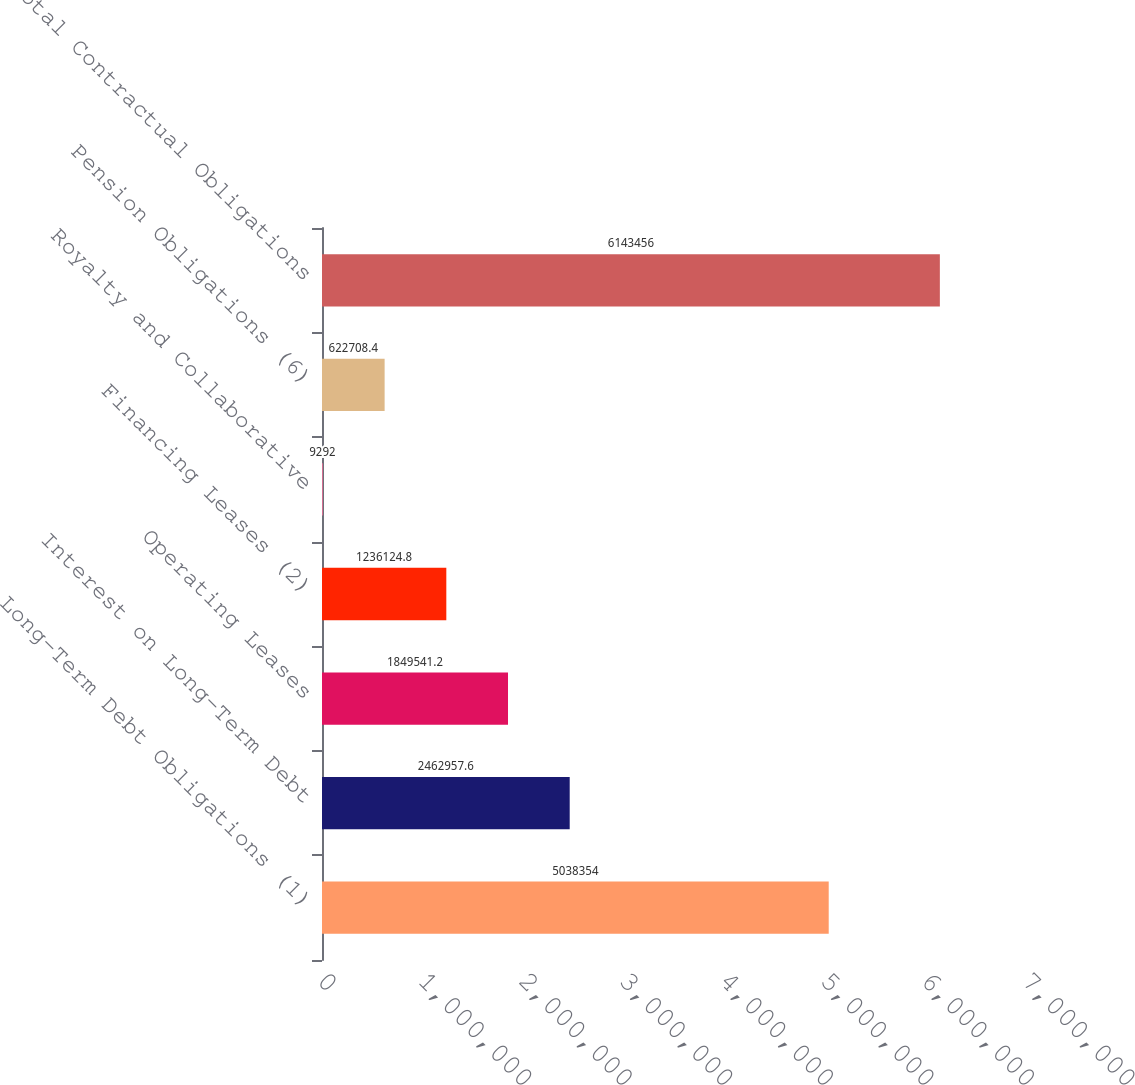Convert chart. <chart><loc_0><loc_0><loc_500><loc_500><bar_chart><fcel>Long-Term Debt Obligations (1)<fcel>Interest on Long-Term Debt<fcel>Operating Leases<fcel>Financing Leases (2)<fcel>Royalty and Collaborative<fcel>Pension Obligations (6)<fcel>Total Contractual Obligations<nl><fcel>5.03835e+06<fcel>2.46296e+06<fcel>1.84954e+06<fcel>1.23612e+06<fcel>9292<fcel>622708<fcel>6.14346e+06<nl></chart> 